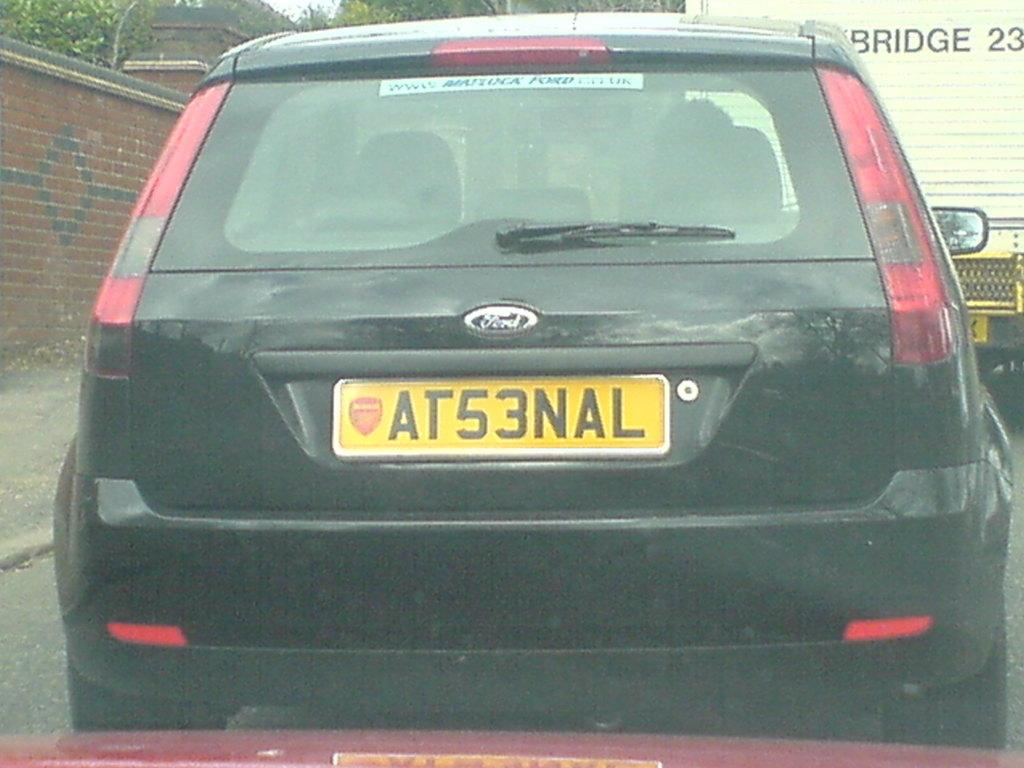<image>
Create a compact narrative representing the image presented. A black car says Ford on the back. 